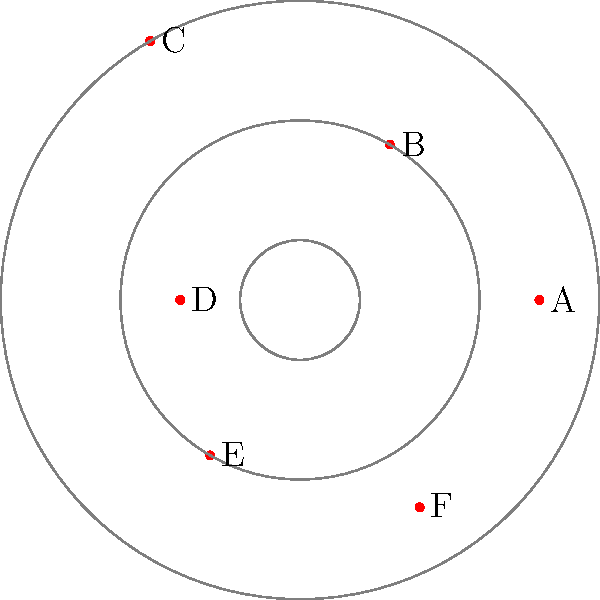In this polar coordinate representation of geopolitical influence spheres, nations A through F are positioned based on their relative influence. If nation C were to form a strategic alliance with its two nearest neighbors, what would be the sum of their combined influence radii? To solve this problem, we need to follow these steps:

1. Identify nation C's position: Nation C is located at angle $2\pi/3$ with a radius of 5.

2. Find C's two nearest neighbors:
   - Nation B is at angle $\pi/3$ with radius 3
   - Nation D is at angle $\pi$ with radius 2

   These are the closest nations to C in terms of angular distance.

3. Calculate the sum of their influence radii:
   $$ \text{Total Influence} = r_C + r_B + r_D $$
   $$ \text{Total Influence} = 5 + 3 + 2 = 10 $$

The sum of the combined influence radii of nation C and its two nearest neighbors is 10.
Answer: 10 